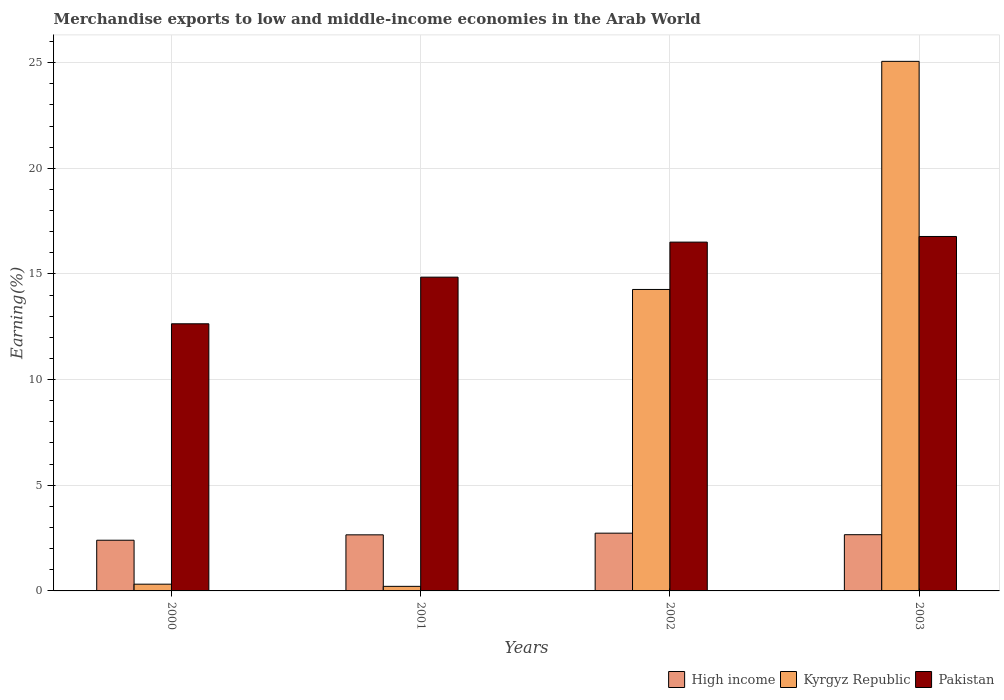How many different coloured bars are there?
Your answer should be compact. 3. How many groups of bars are there?
Ensure brevity in your answer.  4. Are the number of bars on each tick of the X-axis equal?
Provide a short and direct response. Yes. How many bars are there on the 1st tick from the left?
Your answer should be very brief. 3. How many bars are there on the 1st tick from the right?
Offer a terse response. 3. What is the label of the 2nd group of bars from the left?
Your response must be concise. 2001. What is the percentage of amount earned from merchandise exports in Kyrgyz Republic in 2003?
Keep it short and to the point. 25.06. Across all years, what is the maximum percentage of amount earned from merchandise exports in High income?
Ensure brevity in your answer.  2.73. Across all years, what is the minimum percentage of amount earned from merchandise exports in Pakistan?
Make the answer very short. 12.64. What is the total percentage of amount earned from merchandise exports in Kyrgyz Republic in the graph?
Offer a terse response. 39.86. What is the difference between the percentage of amount earned from merchandise exports in Pakistan in 2002 and that in 2003?
Make the answer very short. -0.27. What is the difference between the percentage of amount earned from merchandise exports in Kyrgyz Republic in 2003 and the percentage of amount earned from merchandise exports in Pakistan in 2002?
Your response must be concise. 8.55. What is the average percentage of amount earned from merchandise exports in High income per year?
Your answer should be compact. 2.61. In the year 2002, what is the difference between the percentage of amount earned from merchandise exports in Pakistan and percentage of amount earned from merchandise exports in Kyrgyz Republic?
Provide a short and direct response. 2.24. What is the ratio of the percentage of amount earned from merchandise exports in High income in 2000 to that in 2002?
Your answer should be compact. 0.88. What is the difference between the highest and the second highest percentage of amount earned from merchandise exports in Kyrgyz Republic?
Offer a very short reply. 10.79. What is the difference between the highest and the lowest percentage of amount earned from merchandise exports in Pakistan?
Provide a succinct answer. 4.13. What does the 1st bar from the left in 2000 represents?
Make the answer very short. High income. Is it the case that in every year, the sum of the percentage of amount earned from merchandise exports in Kyrgyz Republic and percentage of amount earned from merchandise exports in High income is greater than the percentage of amount earned from merchandise exports in Pakistan?
Offer a terse response. No. Are all the bars in the graph horizontal?
Offer a terse response. No. Are the values on the major ticks of Y-axis written in scientific E-notation?
Offer a very short reply. No. Where does the legend appear in the graph?
Provide a succinct answer. Bottom right. How many legend labels are there?
Provide a short and direct response. 3. How are the legend labels stacked?
Ensure brevity in your answer.  Horizontal. What is the title of the graph?
Your answer should be compact. Merchandise exports to low and middle-income economies in the Arab World. Does "Sudan" appear as one of the legend labels in the graph?
Offer a terse response. No. What is the label or title of the X-axis?
Give a very brief answer. Years. What is the label or title of the Y-axis?
Provide a succinct answer. Earning(%). What is the Earning(%) of High income in 2000?
Your response must be concise. 2.4. What is the Earning(%) in Kyrgyz Republic in 2000?
Keep it short and to the point. 0.32. What is the Earning(%) of Pakistan in 2000?
Your response must be concise. 12.64. What is the Earning(%) of High income in 2001?
Provide a succinct answer. 2.65. What is the Earning(%) in Kyrgyz Republic in 2001?
Provide a short and direct response. 0.22. What is the Earning(%) of Pakistan in 2001?
Your answer should be compact. 14.85. What is the Earning(%) in High income in 2002?
Give a very brief answer. 2.73. What is the Earning(%) of Kyrgyz Republic in 2002?
Your answer should be very brief. 14.27. What is the Earning(%) of Pakistan in 2002?
Your answer should be very brief. 16.51. What is the Earning(%) in High income in 2003?
Make the answer very short. 2.66. What is the Earning(%) in Kyrgyz Republic in 2003?
Provide a succinct answer. 25.06. What is the Earning(%) of Pakistan in 2003?
Ensure brevity in your answer.  16.77. Across all years, what is the maximum Earning(%) of High income?
Your response must be concise. 2.73. Across all years, what is the maximum Earning(%) in Kyrgyz Republic?
Your response must be concise. 25.06. Across all years, what is the maximum Earning(%) in Pakistan?
Keep it short and to the point. 16.77. Across all years, what is the minimum Earning(%) in High income?
Provide a short and direct response. 2.4. Across all years, what is the minimum Earning(%) of Kyrgyz Republic?
Your answer should be very brief. 0.22. Across all years, what is the minimum Earning(%) in Pakistan?
Offer a very short reply. 12.64. What is the total Earning(%) of High income in the graph?
Make the answer very short. 10.45. What is the total Earning(%) of Kyrgyz Republic in the graph?
Make the answer very short. 39.86. What is the total Earning(%) in Pakistan in the graph?
Your answer should be compact. 60.77. What is the difference between the Earning(%) of High income in 2000 and that in 2001?
Offer a very short reply. -0.26. What is the difference between the Earning(%) of Kyrgyz Republic in 2000 and that in 2001?
Offer a terse response. 0.1. What is the difference between the Earning(%) in Pakistan in 2000 and that in 2001?
Provide a short and direct response. -2.21. What is the difference between the Earning(%) in High income in 2000 and that in 2002?
Your answer should be very brief. -0.33. What is the difference between the Earning(%) of Kyrgyz Republic in 2000 and that in 2002?
Your answer should be compact. -13.95. What is the difference between the Earning(%) in Pakistan in 2000 and that in 2002?
Your response must be concise. -3.86. What is the difference between the Earning(%) of High income in 2000 and that in 2003?
Your answer should be very brief. -0.26. What is the difference between the Earning(%) of Kyrgyz Republic in 2000 and that in 2003?
Ensure brevity in your answer.  -24.74. What is the difference between the Earning(%) of Pakistan in 2000 and that in 2003?
Offer a terse response. -4.13. What is the difference between the Earning(%) in High income in 2001 and that in 2002?
Provide a succinct answer. -0.08. What is the difference between the Earning(%) of Kyrgyz Republic in 2001 and that in 2002?
Your answer should be very brief. -14.05. What is the difference between the Earning(%) of Pakistan in 2001 and that in 2002?
Make the answer very short. -1.66. What is the difference between the Earning(%) in High income in 2001 and that in 2003?
Offer a terse response. -0.01. What is the difference between the Earning(%) of Kyrgyz Republic in 2001 and that in 2003?
Provide a short and direct response. -24.84. What is the difference between the Earning(%) of Pakistan in 2001 and that in 2003?
Make the answer very short. -1.93. What is the difference between the Earning(%) of High income in 2002 and that in 2003?
Make the answer very short. 0.07. What is the difference between the Earning(%) in Kyrgyz Republic in 2002 and that in 2003?
Provide a succinct answer. -10.79. What is the difference between the Earning(%) of Pakistan in 2002 and that in 2003?
Provide a short and direct response. -0.27. What is the difference between the Earning(%) of High income in 2000 and the Earning(%) of Kyrgyz Republic in 2001?
Provide a short and direct response. 2.18. What is the difference between the Earning(%) of High income in 2000 and the Earning(%) of Pakistan in 2001?
Your answer should be compact. -12.45. What is the difference between the Earning(%) in Kyrgyz Republic in 2000 and the Earning(%) in Pakistan in 2001?
Offer a very short reply. -14.53. What is the difference between the Earning(%) in High income in 2000 and the Earning(%) in Kyrgyz Republic in 2002?
Your answer should be very brief. -11.87. What is the difference between the Earning(%) of High income in 2000 and the Earning(%) of Pakistan in 2002?
Ensure brevity in your answer.  -14.11. What is the difference between the Earning(%) in Kyrgyz Republic in 2000 and the Earning(%) in Pakistan in 2002?
Your response must be concise. -16.19. What is the difference between the Earning(%) in High income in 2000 and the Earning(%) in Kyrgyz Republic in 2003?
Give a very brief answer. -22.66. What is the difference between the Earning(%) of High income in 2000 and the Earning(%) of Pakistan in 2003?
Give a very brief answer. -14.37. What is the difference between the Earning(%) in Kyrgyz Republic in 2000 and the Earning(%) in Pakistan in 2003?
Offer a terse response. -16.45. What is the difference between the Earning(%) in High income in 2001 and the Earning(%) in Kyrgyz Republic in 2002?
Make the answer very short. -11.61. What is the difference between the Earning(%) in High income in 2001 and the Earning(%) in Pakistan in 2002?
Ensure brevity in your answer.  -13.85. What is the difference between the Earning(%) in Kyrgyz Republic in 2001 and the Earning(%) in Pakistan in 2002?
Your answer should be very brief. -16.29. What is the difference between the Earning(%) of High income in 2001 and the Earning(%) of Kyrgyz Republic in 2003?
Ensure brevity in your answer.  -22.41. What is the difference between the Earning(%) of High income in 2001 and the Earning(%) of Pakistan in 2003?
Provide a short and direct response. -14.12. What is the difference between the Earning(%) of Kyrgyz Republic in 2001 and the Earning(%) of Pakistan in 2003?
Keep it short and to the point. -16.56. What is the difference between the Earning(%) in High income in 2002 and the Earning(%) in Kyrgyz Republic in 2003?
Keep it short and to the point. -22.33. What is the difference between the Earning(%) of High income in 2002 and the Earning(%) of Pakistan in 2003?
Offer a terse response. -14.04. What is the difference between the Earning(%) of Kyrgyz Republic in 2002 and the Earning(%) of Pakistan in 2003?
Provide a succinct answer. -2.51. What is the average Earning(%) in High income per year?
Provide a succinct answer. 2.61. What is the average Earning(%) in Kyrgyz Republic per year?
Your answer should be very brief. 9.97. What is the average Earning(%) in Pakistan per year?
Your response must be concise. 15.19. In the year 2000, what is the difference between the Earning(%) of High income and Earning(%) of Kyrgyz Republic?
Make the answer very short. 2.08. In the year 2000, what is the difference between the Earning(%) in High income and Earning(%) in Pakistan?
Provide a short and direct response. -10.24. In the year 2000, what is the difference between the Earning(%) of Kyrgyz Republic and Earning(%) of Pakistan?
Your answer should be very brief. -12.32. In the year 2001, what is the difference between the Earning(%) of High income and Earning(%) of Kyrgyz Republic?
Offer a very short reply. 2.44. In the year 2001, what is the difference between the Earning(%) in High income and Earning(%) in Pakistan?
Provide a succinct answer. -12.19. In the year 2001, what is the difference between the Earning(%) of Kyrgyz Republic and Earning(%) of Pakistan?
Provide a short and direct response. -14.63. In the year 2002, what is the difference between the Earning(%) of High income and Earning(%) of Kyrgyz Republic?
Provide a short and direct response. -11.53. In the year 2002, what is the difference between the Earning(%) in High income and Earning(%) in Pakistan?
Keep it short and to the point. -13.77. In the year 2002, what is the difference between the Earning(%) of Kyrgyz Republic and Earning(%) of Pakistan?
Provide a succinct answer. -2.24. In the year 2003, what is the difference between the Earning(%) of High income and Earning(%) of Kyrgyz Republic?
Offer a terse response. -22.4. In the year 2003, what is the difference between the Earning(%) in High income and Earning(%) in Pakistan?
Provide a succinct answer. -14.11. In the year 2003, what is the difference between the Earning(%) of Kyrgyz Republic and Earning(%) of Pakistan?
Make the answer very short. 8.29. What is the ratio of the Earning(%) of High income in 2000 to that in 2001?
Make the answer very short. 0.9. What is the ratio of the Earning(%) in Kyrgyz Republic in 2000 to that in 2001?
Provide a succinct answer. 1.47. What is the ratio of the Earning(%) in Pakistan in 2000 to that in 2001?
Provide a short and direct response. 0.85. What is the ratio of the Earning(%) in High income in 2000 to that in 2002?
Your answer should be very brief. 0.88. What is the ratio of the Earning(%) in Kyrgyz Republic in 2000 to that in 2002?
Provide a succinct answer. 0.02. What is the ratio of the Earning(%) of Pakistan in 2000 to that in 2002?
Make the answer very short. 0.77. What is the ratio of the Earning(%) of High income in 2000 to that in 2003?
Provide a short and direct response. 0.9. What is the ratio of the Earning(%) of Kyrgyz Republic in 2000 to that in 2003?
Make the answer very short. 0.01. What is the ratio of the Earning(%) in Pakistan in 2000 to that in 2003?
Give a very brief answer. 0.75. What is the ratio of the Earning(%) of High income in 2001 to that in 2002?
Ensure brevity in your answer.  0.97. What is the ratio of the Earning(%) of Kyrgyz Republic in 2001 to that in 2002?
Your answer should be compact. 0.02. What is the ratio of the Earning(%) of Pakistan in 2001 to that in 2002?
Your response must be concise. 0.9. What is the ratio of the Earning(%) of High income in 2001 to that in 2003?
Offer a very short reply. 1. What is the ratio of the Earning(%) in Kyrgyz Republic in 2001 to that in 2003?
Ensure brevity in your answer.  0.01. What is the ratio of the Earning(%) of Pakistan in 2001 to that in 2003?
Provide a short and direct response. 0.89. What is the ratio of the Earning(%) of High income in 2002 to that in 2003?
Provide a succinct answer. 1.03. What is the ratio of the Earning(%) of Kyrgyz Republic in 2002 to that in 2003?
Provide a short and direct response. 0.57. What is the ratio of the Earning(%) in Pakistan in 2002 to that in 2003?
Provide a short and direct response. 0.98. What is the difference between the highest and the second highest Earning(%) of High income?
Offer a very short reply. 0.07. What is the difference between the highest and the second highest Earning(%) of Kyrgyz Republic?
Give a very brief answer. 10.79. What is the difference between the highest and the second highest Earning(%) in Pakistan?
Your answer should be compact. 0.27. What is the difference between the highest and the lowest Earning(%) of High income?
Offer a very short reply. 0.33. What is the difference between the highest and the lowest Earning(%) of Kyrgyz Republic?
Offer a very short reply. 24.84. What is the difference between the highest and the lowest Earning(%) of Pakistan?
Ensure brevity in your answer.  4.13. 